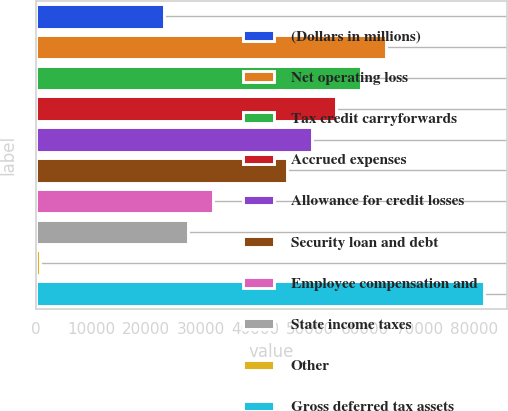<chart> <loc_0><loc_0><loc_500><loc_500><bar_chart><fcel>(Dollars in millions)<fcel>Net operating loss<fcel>Tax credit carryforwards<fcel>Accrued expenses<fcel>Allowance for credit losses<fcel>Security loan and debt<fcel>Employee compensation and<fcel>State income taxes<fcel>Other<fcel>Gross deferred tax assets<nl><fcel>23251.5<fcel>63804.6<fcel>59298.7<fcel>54792.8<fcel>50286.9<fcel>45781<fcel>32263.3<fcel>27757.4<fcel>722<fcel>81828.2<nl></chart> 